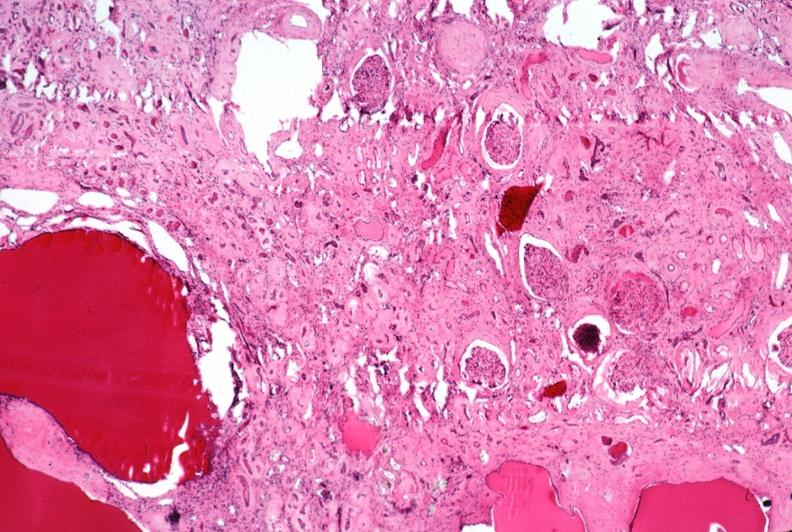does this image show kidney, adult polycystic kidney?
Answer the question using a single word or phrase. Yes 